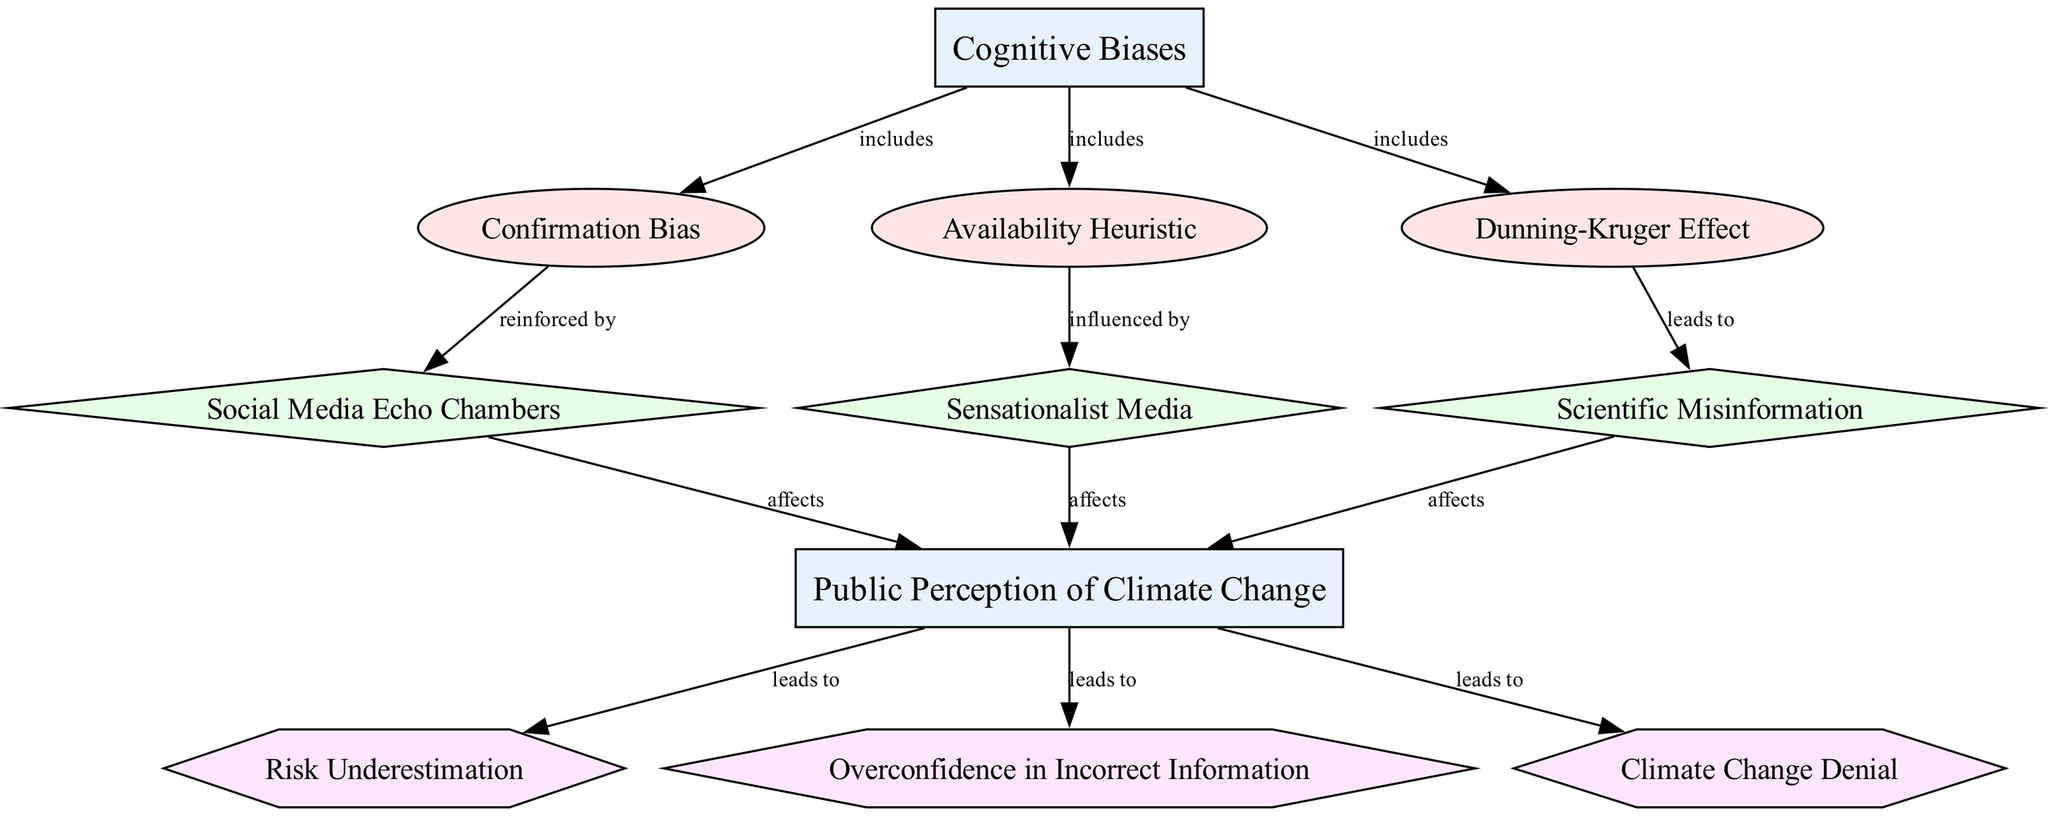What are the three types of cognitive biases shown in the diagram? The diagram lists three cognitive biases: Confirmation Bias, Availability Heuristic, and Dunning-Kruger Effect under the 'Cognitive Biases' category node.
Answer: Confirmation Bias, Availability Heuristic, Dunning-Kruger Effect How does Confirmation Bias affect Public Perception? The diagram indicates that Confirmation Bias is reinforced by Social Media Echo Chambers, which then affects Public Perception of Climate Change.
Answer: It affects through Social Media Echo Chambers What is the relationship between Dunning-Kruger Effect and Scientific Misinformation? The diagram shows that Dunning-Kruger Effect leads to Scientific Misinformation. This means that overconfidence in one's understanding can result in incorrect information being accepted.
Answer: Leads to Which outcome results from Public Perception of Climate Change? The diagram illustrates three outcomes stemming from Public Perception: Risk Underestimation, Overconfidence in Incorrect Information, and Climate Change Denial.
Answer: Risk Underestimation, Overconfidence in Incorrect Information, Climate Change Denial How many edges are connecting the factors to Public Perception? Counting from the diagram, there are three edges connecting factors (Social Media Echo Chambers, Sensationalist Media, Scientific Misinformation) to Public Perception.
Answer: Three What cognitive bias influences the Availability Heuristic? The diagram states that Availability Heuristic is influenced by Sensationalist Media which emphasizes how certain events or issues are portrayed in the media.
Answer: Sensationalist Media What does the flow from Public Perception lead to? The flow from Public Perception leads to three specific outcomes: Risk Underestimation, Overconfidence in Incorrect Information, and Climate Change Denial according to the diagram.
Answer: Risk Underestimation, Overconfidence in Incorrect Information, Climate Change Denial In total, how many nodes are present in the diagram? The diagram consists of ten nodes in total, which include cognitive biases, public perception, factors, and outcomes based on the provided data structure.
Answer: Ten 